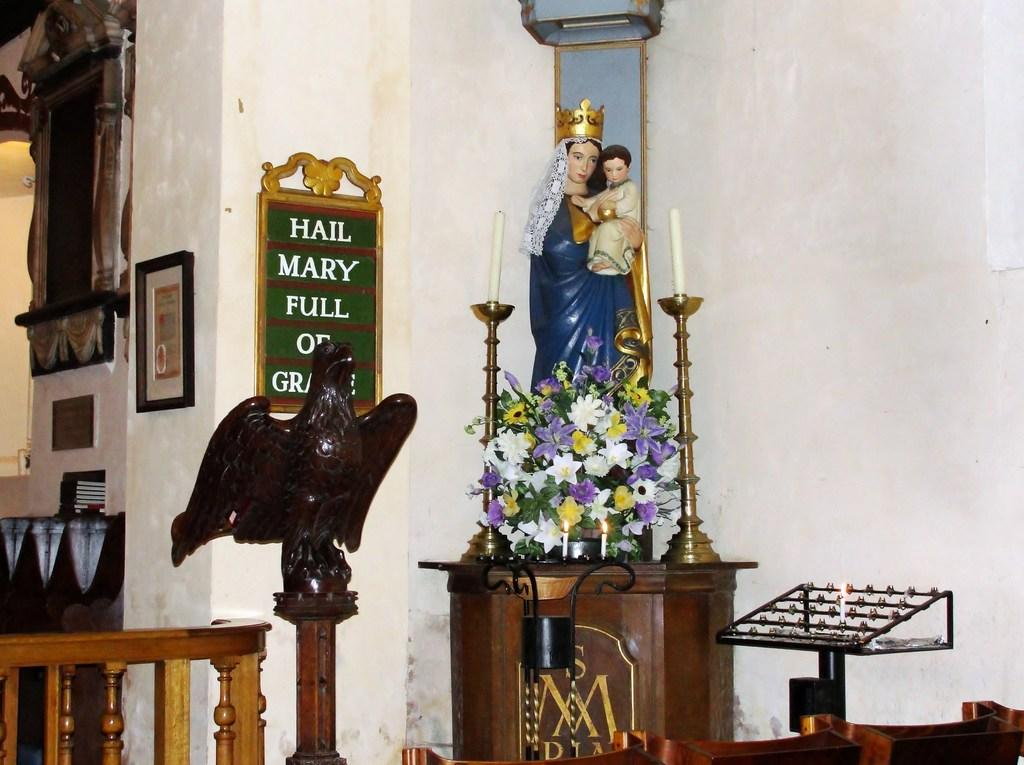What is the main subject of the image? The main subject of the subject of the image is a statue of a woman holding a person. What other objects are near the statue? There are candles beside the statue. What can be seen at the bottom of the image? There are flowers at the bottom of the image. What other statue is present in the image? There is a statue of an eagle on the left side of the image. Can you tell me how many jars are placed on the dock in the image? There is no dock or jar present in the image. What type of island can be seen in the background of the image? There is no island visible in the image. 